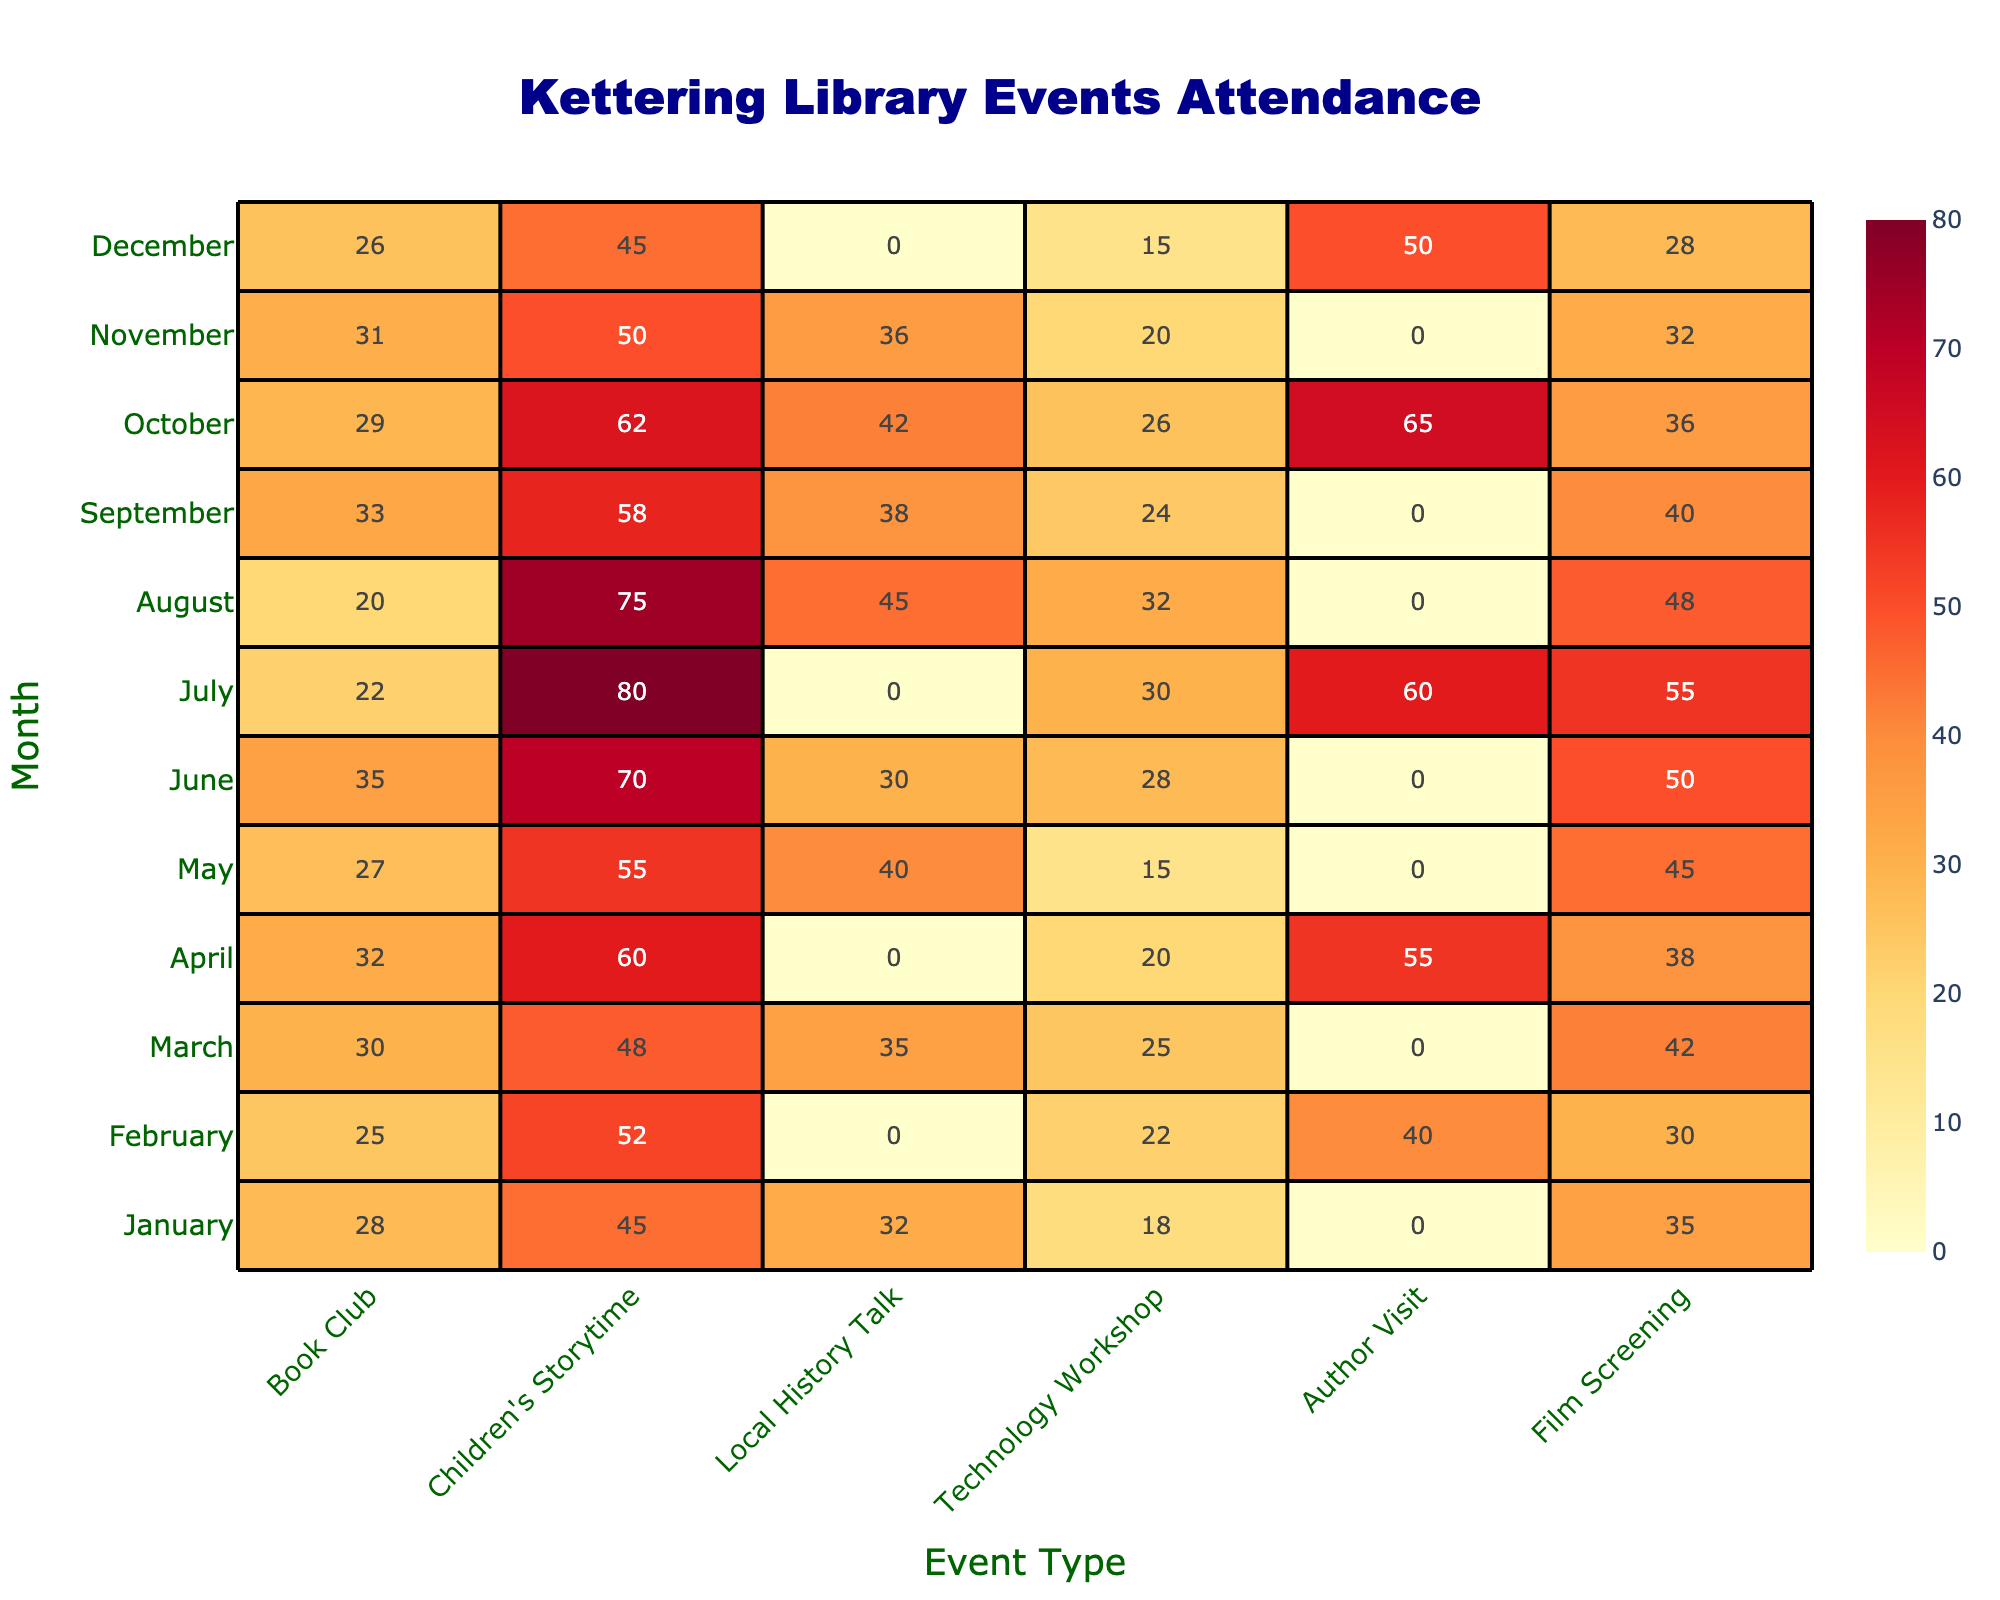What was the highest attendance for Children's Storytime? Looking at the table, June has the highest attendance for Children's Storytime with 70 participants.
Answer: 70 In which month was the attendance for Author Visits the highest? The highest attendance for Author Visits was in October, with 65 participants.
Answer: October What is the average attendance for Local History Talks throughout the year? Adding the attendance for Local History Talks from all months gives (32 + 0 + 35 + 0 + 40 + 30 + 0 + 45 + 38 + 42 + 36 + 0) = 286. There are 12 months, so the average is 286/12 = 23.83, which rounds to 24.
Answer: 24 Did any month see higher attendance for Film Screenings than Technology Workshops? By comparing the numbers, in July, Film Screenings had 55 attendees, while Technology Workshops had 30. Thus, July is an example where Film Screenings were higher.
Answer: Yes What month had the lowest total attendance across all events? Adding the total attendance for each month shows December has the lowest total (26 + 45 + 0 + 15 + 50 + 28) = 164, compared to others.
Answer: December Which event type had the lowest attendance in January? In January, Author Visits had the lowest attendance, with 0 participants.
Answer: Author Visit If you combine the attendance from March and April for Technology Workshops, what is the total? In March, there were 25 attendees for Technology Workshops and in April there were 20, so the total is 25 + 20 = 45.
Answer: 45 Which month had more attendance for Book Clubs, April or June? April had 32 attendees for Book Clubs, while June had 35. Comparing these shows that June had the higher attendance.
Answer: June Calculate the total attendance for all events in May. Adding the attendance for May: 27 (Book Club) + 55 (Children's Storytime) + 40 (Local History Talk) + 15 (Technology Workshop) + 0 (Author Visit) + 45 (Film Screening) gives 27 + 55 + 40 + 15 + 0 + 45 = 182.
Answer: 182 Was there any month where attendance for Technology Workshops reached over 25? The months where Technology Workshops had more than 25 attendees are March (25), July (30), and June (28), so there were multiple months over 25 attendees.
Answer: Yes 